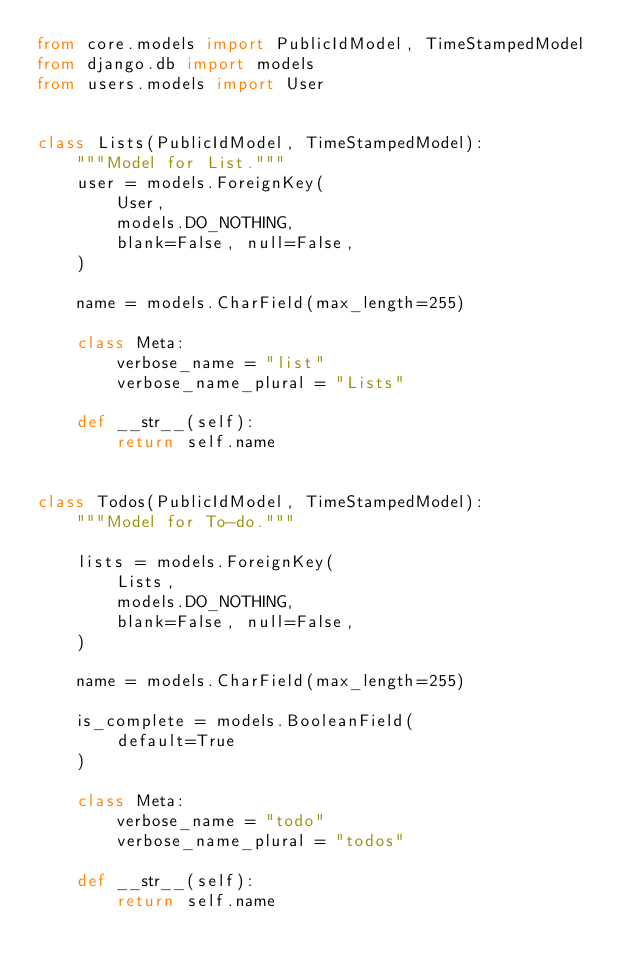<code> <loc_0><loc_0><loc_500><loc_500><_Python_>from core.models import PublicIdModel, TimeStampedModel
from django.db import models
from users.models import User


class Lists(PublicIdModel, TimeStampedModel):
    """Model for List."""
    user = models.ForeignKey(
        User,
        models.DO_NOTHING,
        blank=False, null=False,
    )

    name = models.CharField(max_length=255)

    class Meta:
        verbose_name = "list"
        verbose_name_plural = "Lists"

    def __str__(self):
        return self.name


class Todos(PublicIdModel, TimeStampedModel):
    """Model for To-do."""

    lists = models.ForeignKey(
        Lists,
        models.DO_NOTHING,
        blank=False, null=False,
    )

    name = models.CharField(max_length=255)

    is_complete = models.BooleanField(
        default=True
    )

    class Meta:
        verbose_name = "todo"
        verbose_name_plural = "todos"

    def __str__(self):
        return self.name
</code> 